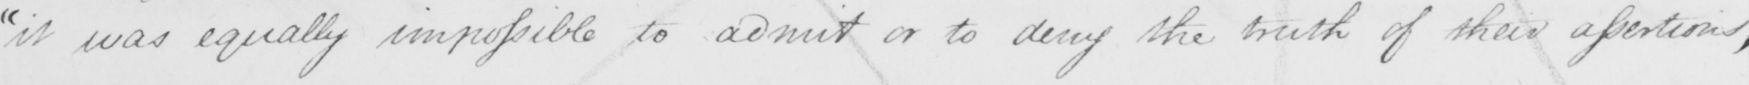Please transcribe the handwritten text in this image. " it was equally impossible to admit or to deny the truth of their assertions , 